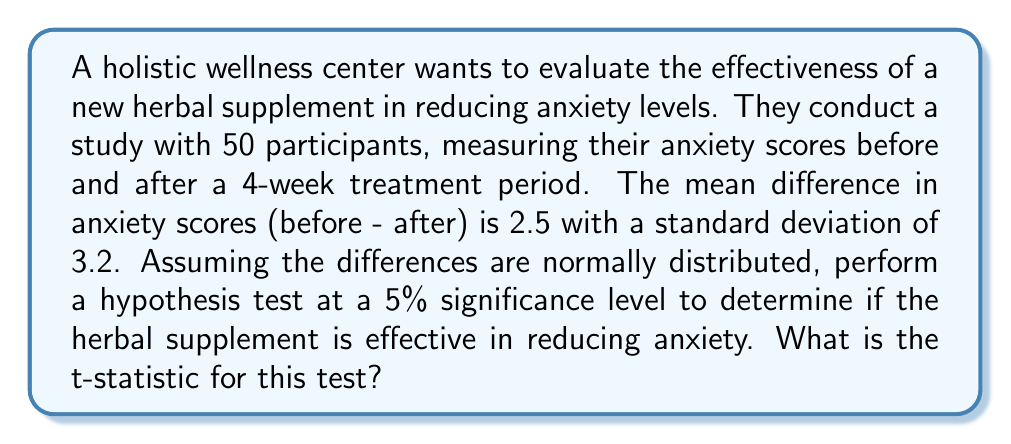Show me your answer to this math problem. To analyze the effectiveness of the herbal supplement, we'll use a one-sample t-test. Our null hypothesis is that the mean difference in anxiety scores is 0 (no effect), and our alternative hypothesis is that the mean difference is greater than 0 (anxiety reduction).

Given:
- Sample size: $n = 50$
- Mean difference: $\bar{x} = 2.5$
- Standard deviation of differences: $s = 3.2$
- Significance level: $\alpha = 0.05$

Step 1: Calculate the standard error of the mean (SEM).
$$ SEM = \frac{s}{\sqrt{n}} = \frac{3.2}{\sqrt{50}} = 0.4525 $$

Step 2: Calculate the t-statistic.
The t-statistic is given by the formula:
$$ t = \frac{\bar{x} - \mu_0}{SEM} $$
Where $\mu_0$ is the hypothesized population mean (0 in this case).

$$ t = \frac{2.5 - 0}{0.4525} = 5.5249 $$

This t-statistic represents the number of standard errors that the sample mean differs from the hypothesized population mean.
Answer: The t-statistic for this hypothesis test is 5.5249. 